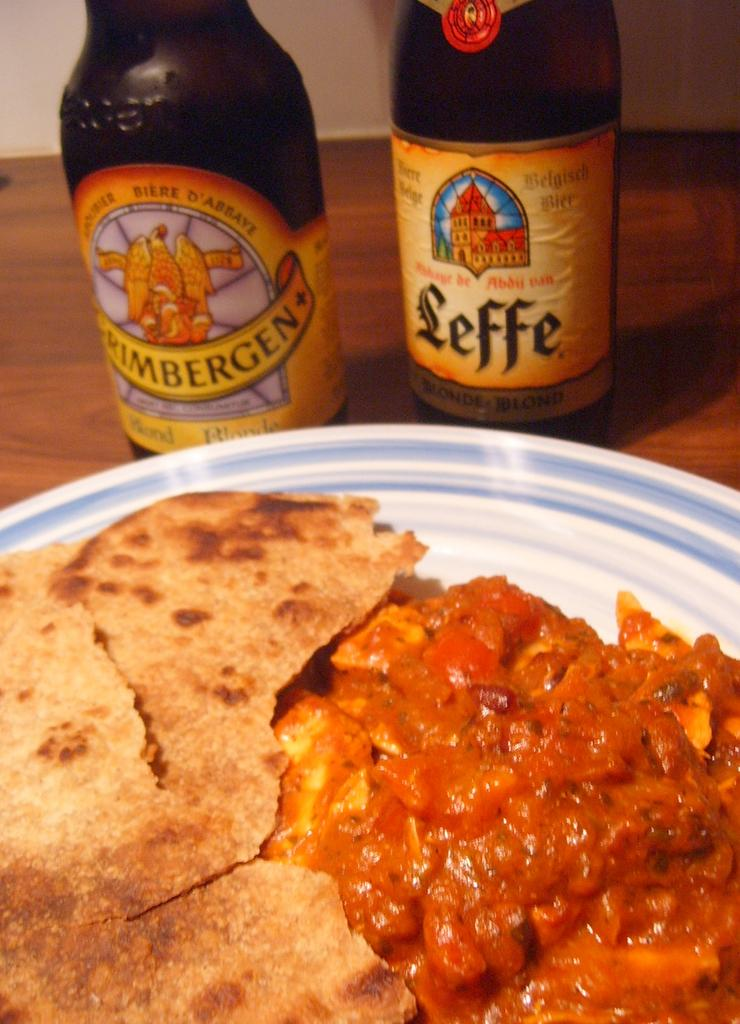<image>
Provide a brief description of the given image. A brown bottle of beer with a yellow label that says Leffe. 